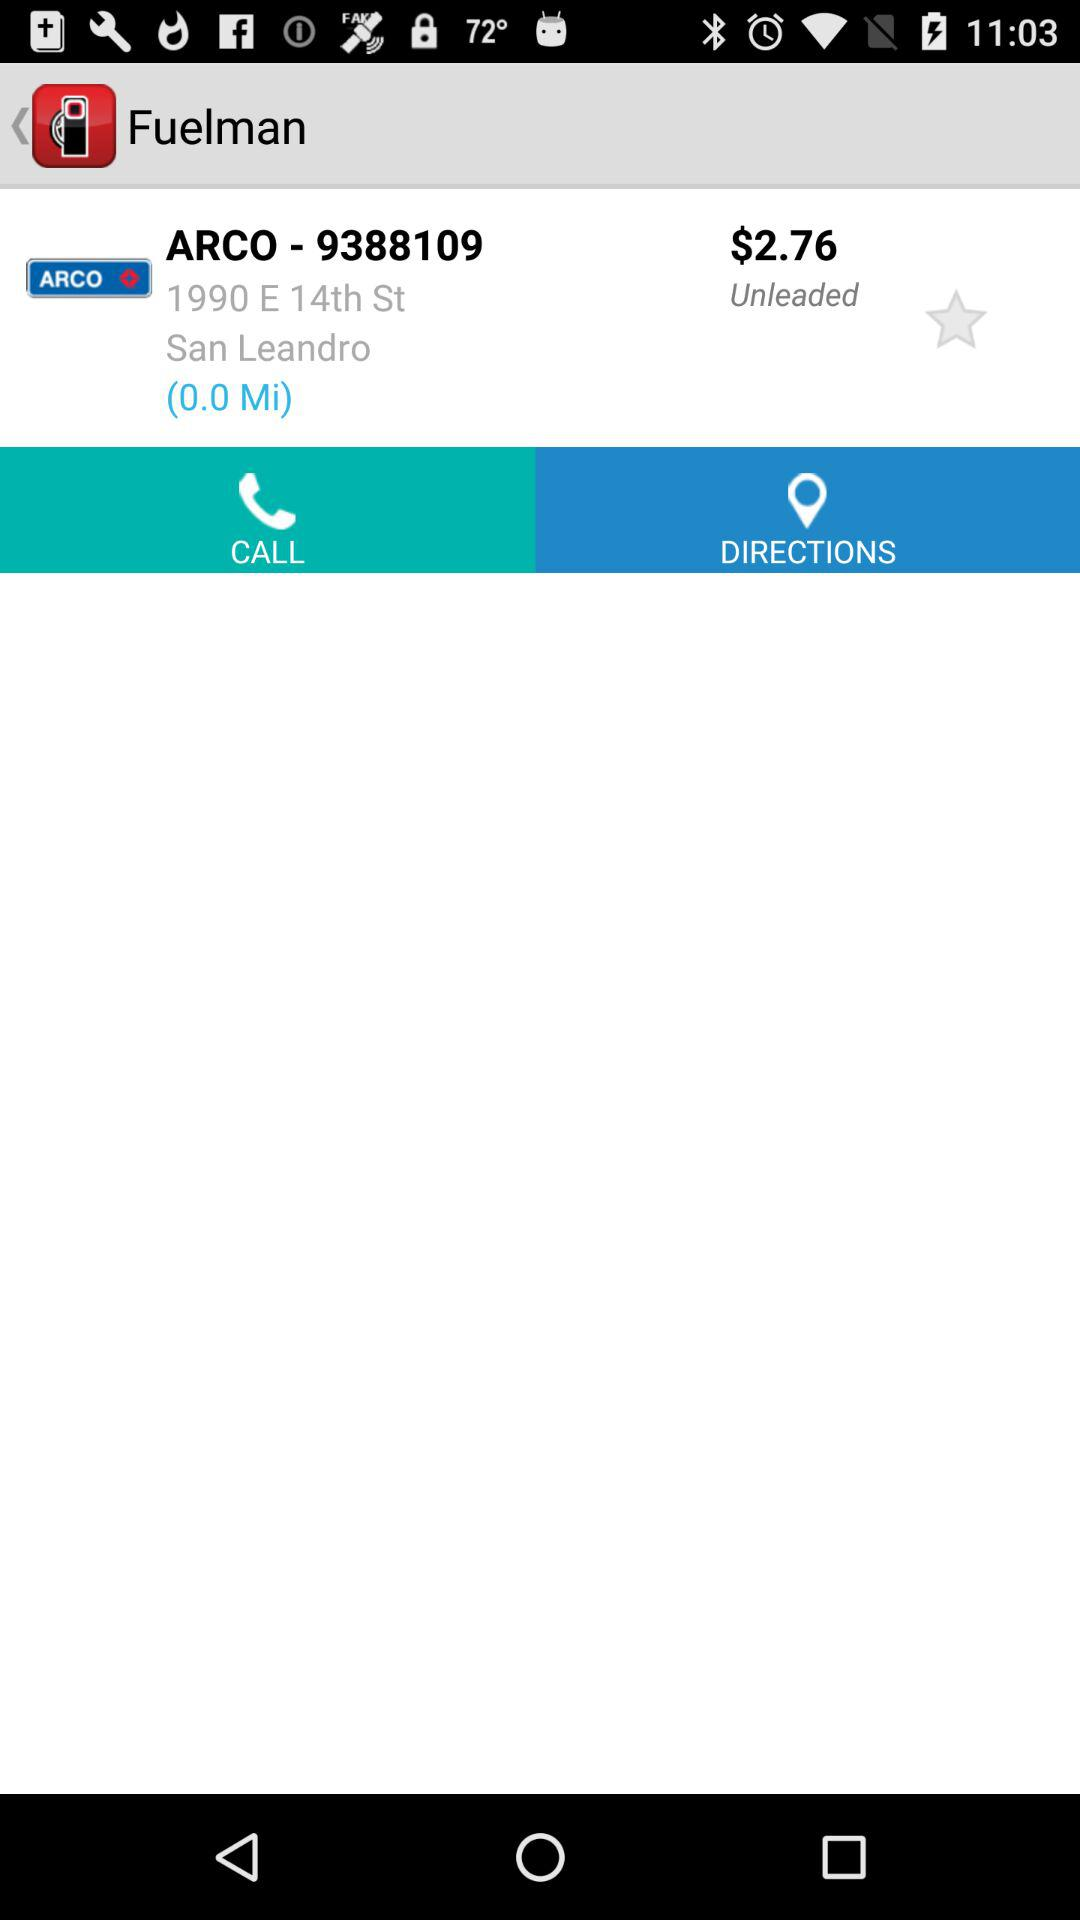What is the displayed price? The displayed price is $2.76. 